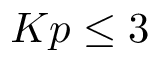<formula> <loc_0><loc_0><loc_500><loc_500>K p \leq 3</formula> 